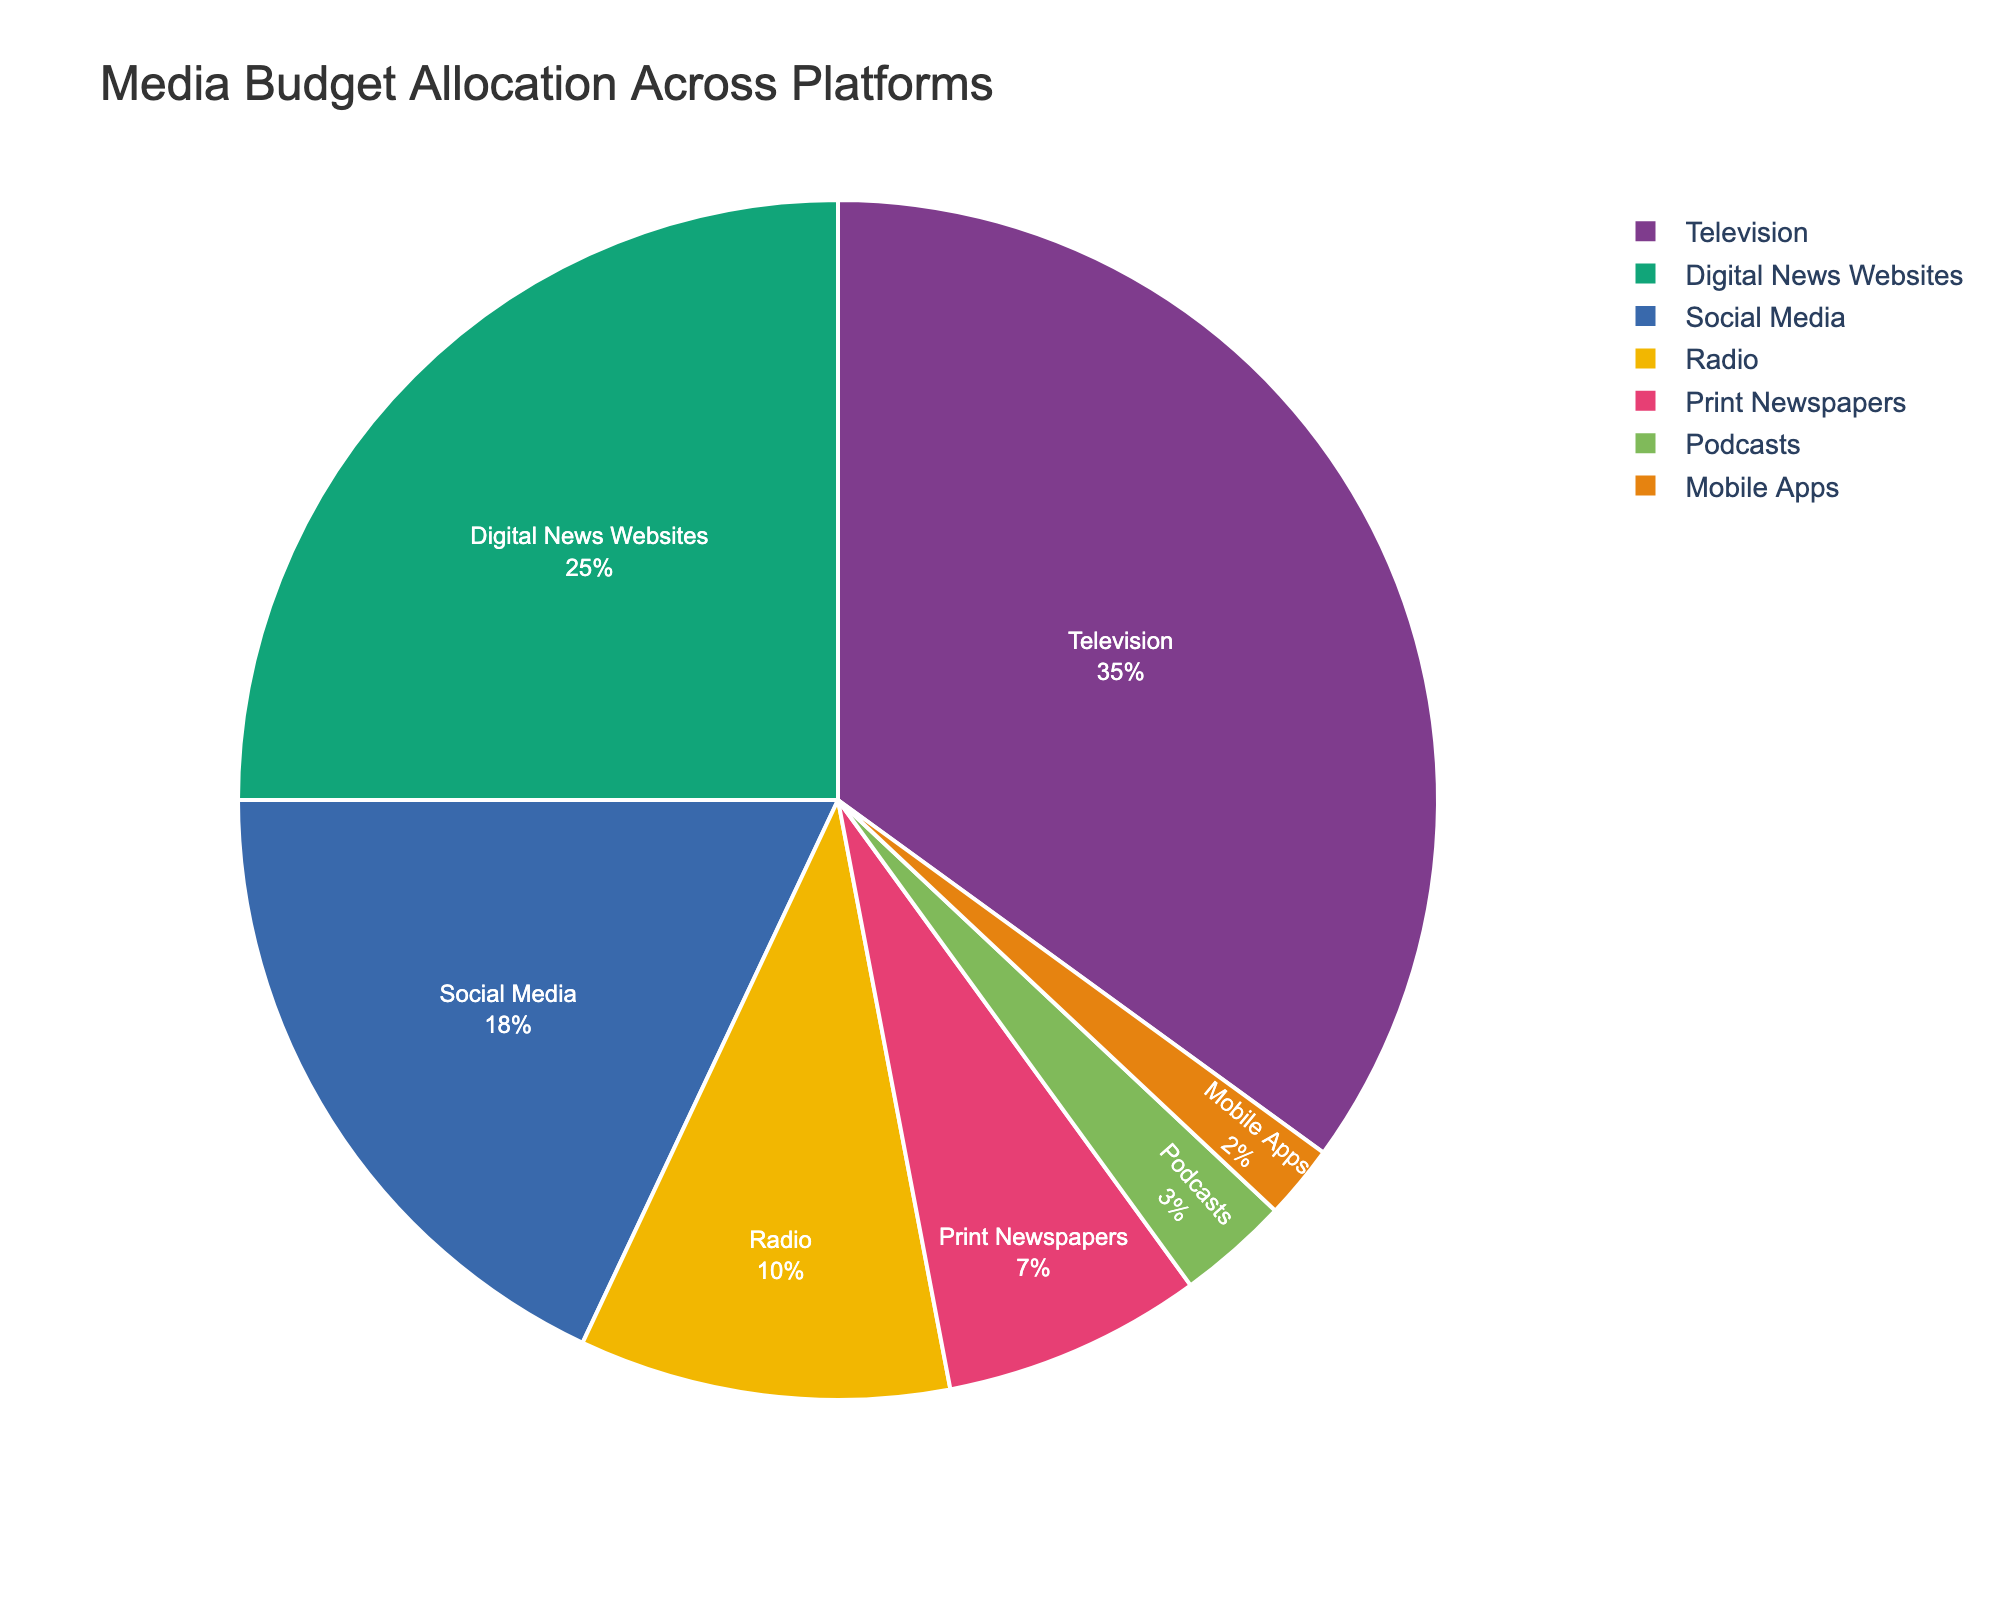What's the largest allocation for a single platform? The largest wedge in the pie chart represents the platform with the highest budget allocation. According to the chart, Television has the largest allocation with 35%.
Answer: Television, 35% Which platform has the smallest budget allocation? To identify the smallest allocation, find the smallest wedge in the pie chart. The smallest allocation is for Mobile Apps, which has 2%.
Answer: Mobile Apps, 2% What is the combined budget allocation for Print Newspapers and Podcasts? Sum the budget allocations for Print Newspapers and Podcasts. According to the chart, Print Newspapers have 7% and Podcasts have 3%, so 7% + 3% = 10%.
Answer: 10% How much more budget is allocated to Television compared to Radio? Subtract the budget allocation for Radio from the allocation for Television. Television has 35% and Radio has 10%, so 35% - 10% = 25%.
Answer: 25% Which has a higher budget allocation: Social Media or Digital News Websites? Compare the budget allocations for Social Media and Digital News Websites. Social Media has 18% and Digital News Websites have 25%, so Digital News Websites have a higher allocation.
Answer: Digital News Websites What proportion of the budget is allocated to Social Media? Social Media's budget allocation is indicated by its wedge in the pie chart, which shows 18%.
Answer: 18% Is the budget allocation for Social Media greater or less than that for Television? Compare the visual sizes of the wedges for Social Media and Television. Social Media has 18%, and Television has 35%. Therefore, Social Media has a smaller allocation than Television.
Answer: Less What is the total budget allocation for all digital platforms (Digital News Websites, Social Media, Mobile Apps)? Add the budget allocations for Digital News Websites, Social Media, and Mobile Apps. Digital News Websites have 25%, Social Media has 18%, and Mobile Apps have 2%. So, 25% + 18% + 2% = 45%.
Answer: 45% How does the allocation for Podcasts compare to that for Print Newspapers? Compare the budget allocations for Podcasts and Print Newspapers. Podcasts have 3%, and Print Newspapers have 7%. Therefore, Print Newspapers have a bigger allocation.
Answer: Print Newspapers have a bigger allocation Which platforms have a budget allocation below 10%? Identify the wedges with allocations below 10%. According to the chart, Radio has 10%, so the platforms below 10% are Print Newspapers (7%), Podcasts (3%), and Mobile Apps (2%).
Answer: Print Newspapers, Podcasts, Mobile Apps 